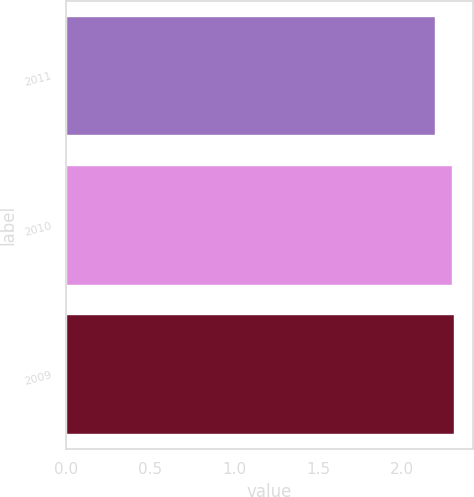Convert chart to OTSL. <chart><loc_0><loc_0><loc_500><loc_500><bar_chart><fcel>2011<fcel>2010<fcel>2009<nl><fcel>2.2<fcel>2.3<fcel>2.31<nl></chart> 